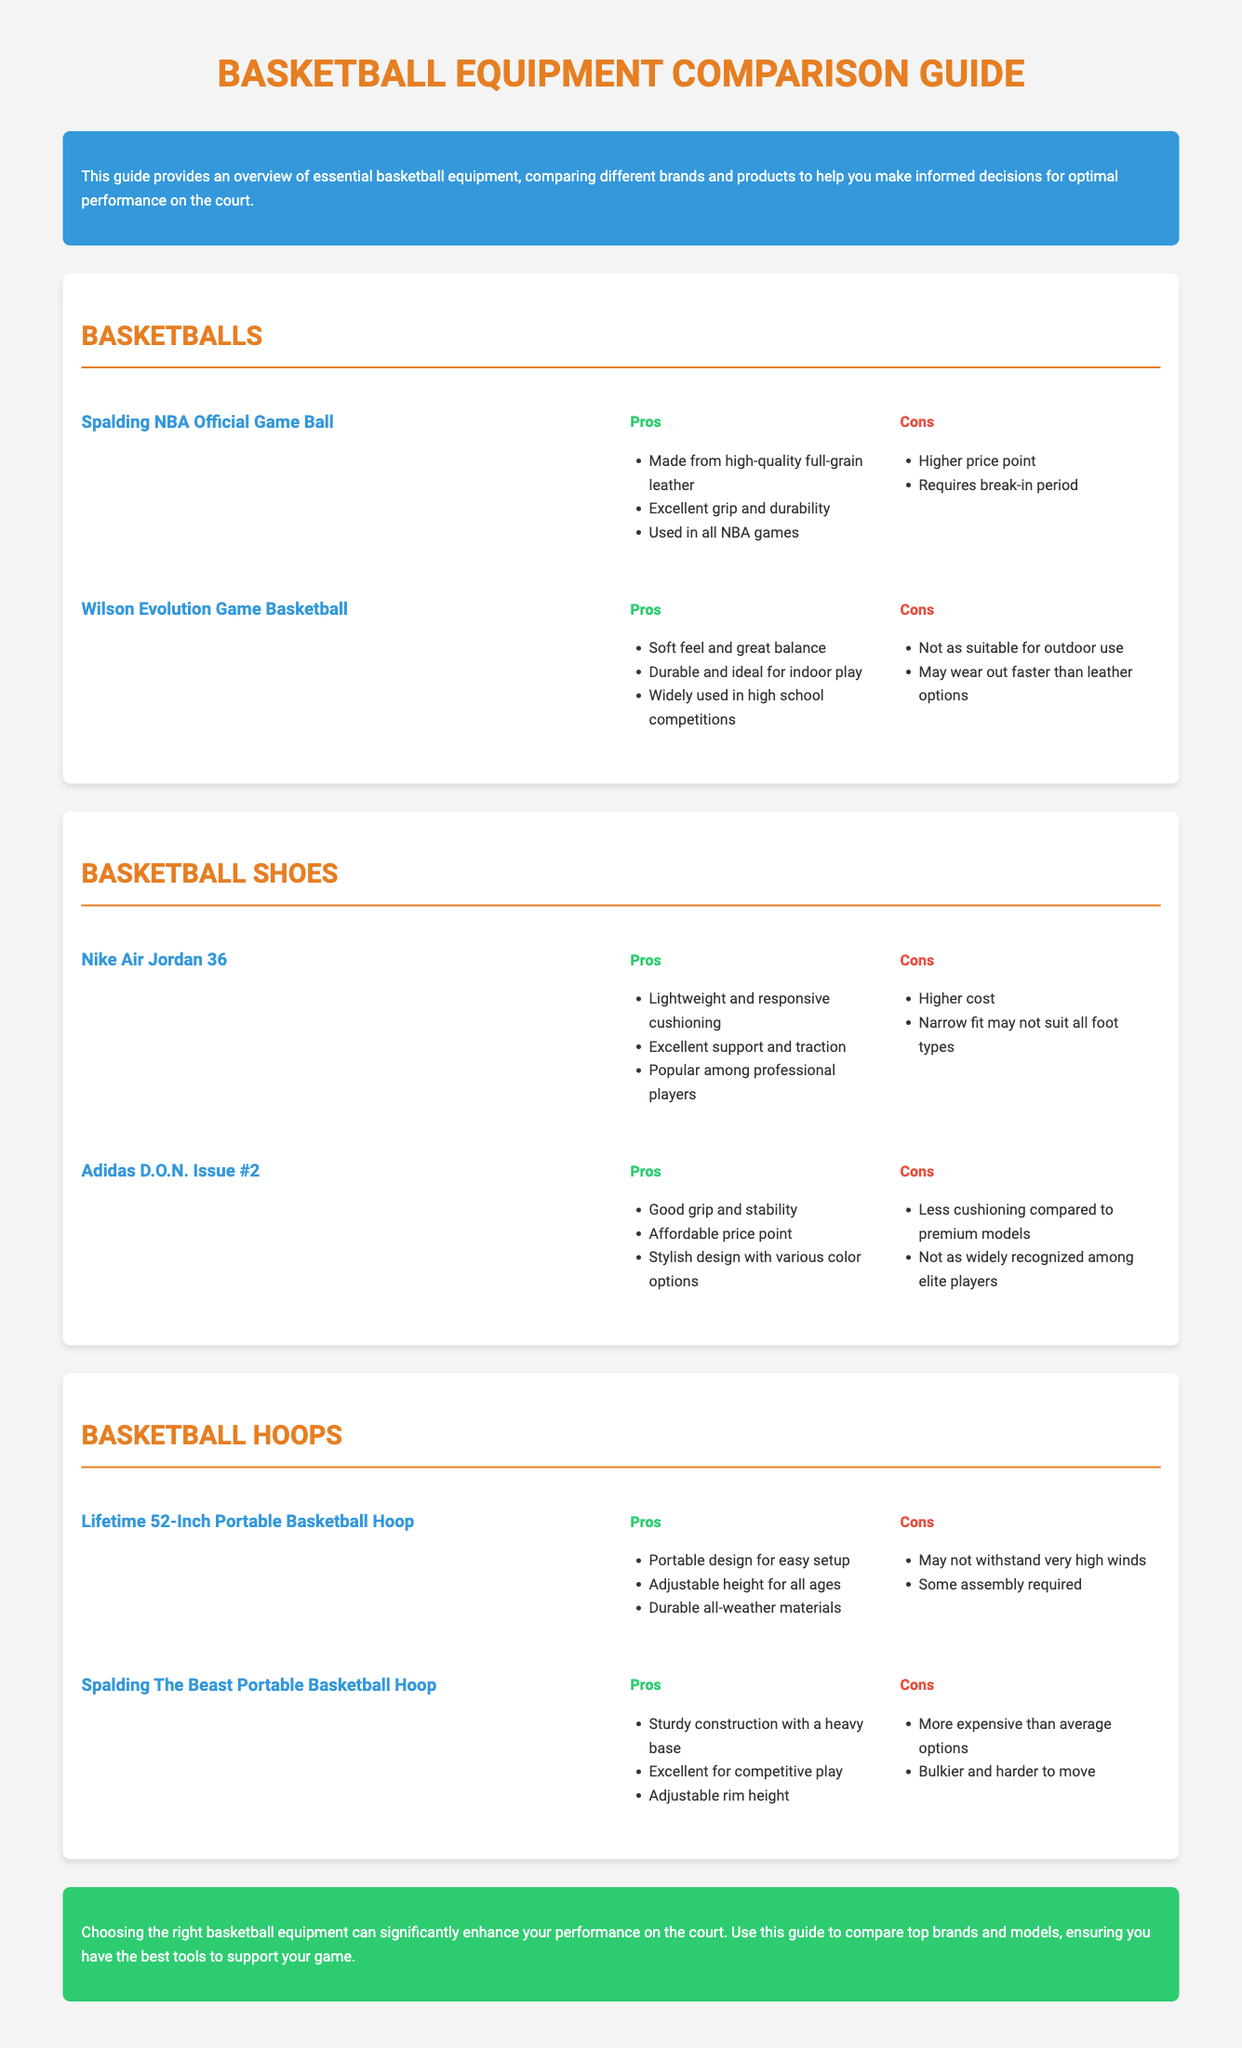What is the name of the official NBA game ball? The document mentions the Spalding NBA Official Game Ball as the official NBA game ball.
Answer: Spalding NBA Official Game Ball What are the main pros of the Wilson Evolution Game Basketball? The pros include a soft feel, great balance, and durability for indoor play.
Answer: Soft feel and great balance, durable and ideal for indoor play What are the cons of the Nike Air Jordan 36? The cons listed are higher cost and narrow fit may not suit all foot types.
Answer: Higher cost, narrow fit may not suit all foot types Which basketball hoop is noted for its portable design? The Lifetime 52-Inch Portable Basketball Hoop is specifically mentioned for its portable design.
Answer: Lifetime 52-Inch Portable Basketball Hoop What is the primary disadvantage of the Spalding The Beast Portable Basketball Hoop? It is mentioned that it is more expensive than average options as a primary disadvantage.
Answer: More expensive than average options Which basketball shoe is recognized for its stylish design? The Adidas D.O.N. Issue #2 is identified for its stylish design with various color options.
Answer: Adidas D.O.N. Issue #2 How many main categories of basketball equipment are compared in this guide? The document lists three main categories: Basketballs, Basketball Shoes, and Basketball Hoops.
Answer: Three What is the main focus of this Basketball Equipment Comparison Guide? The main focus of the guide is to help make informed decisions for optimal performance by comparing different brands and products.
Answer: Inform decisions for optimal performance 